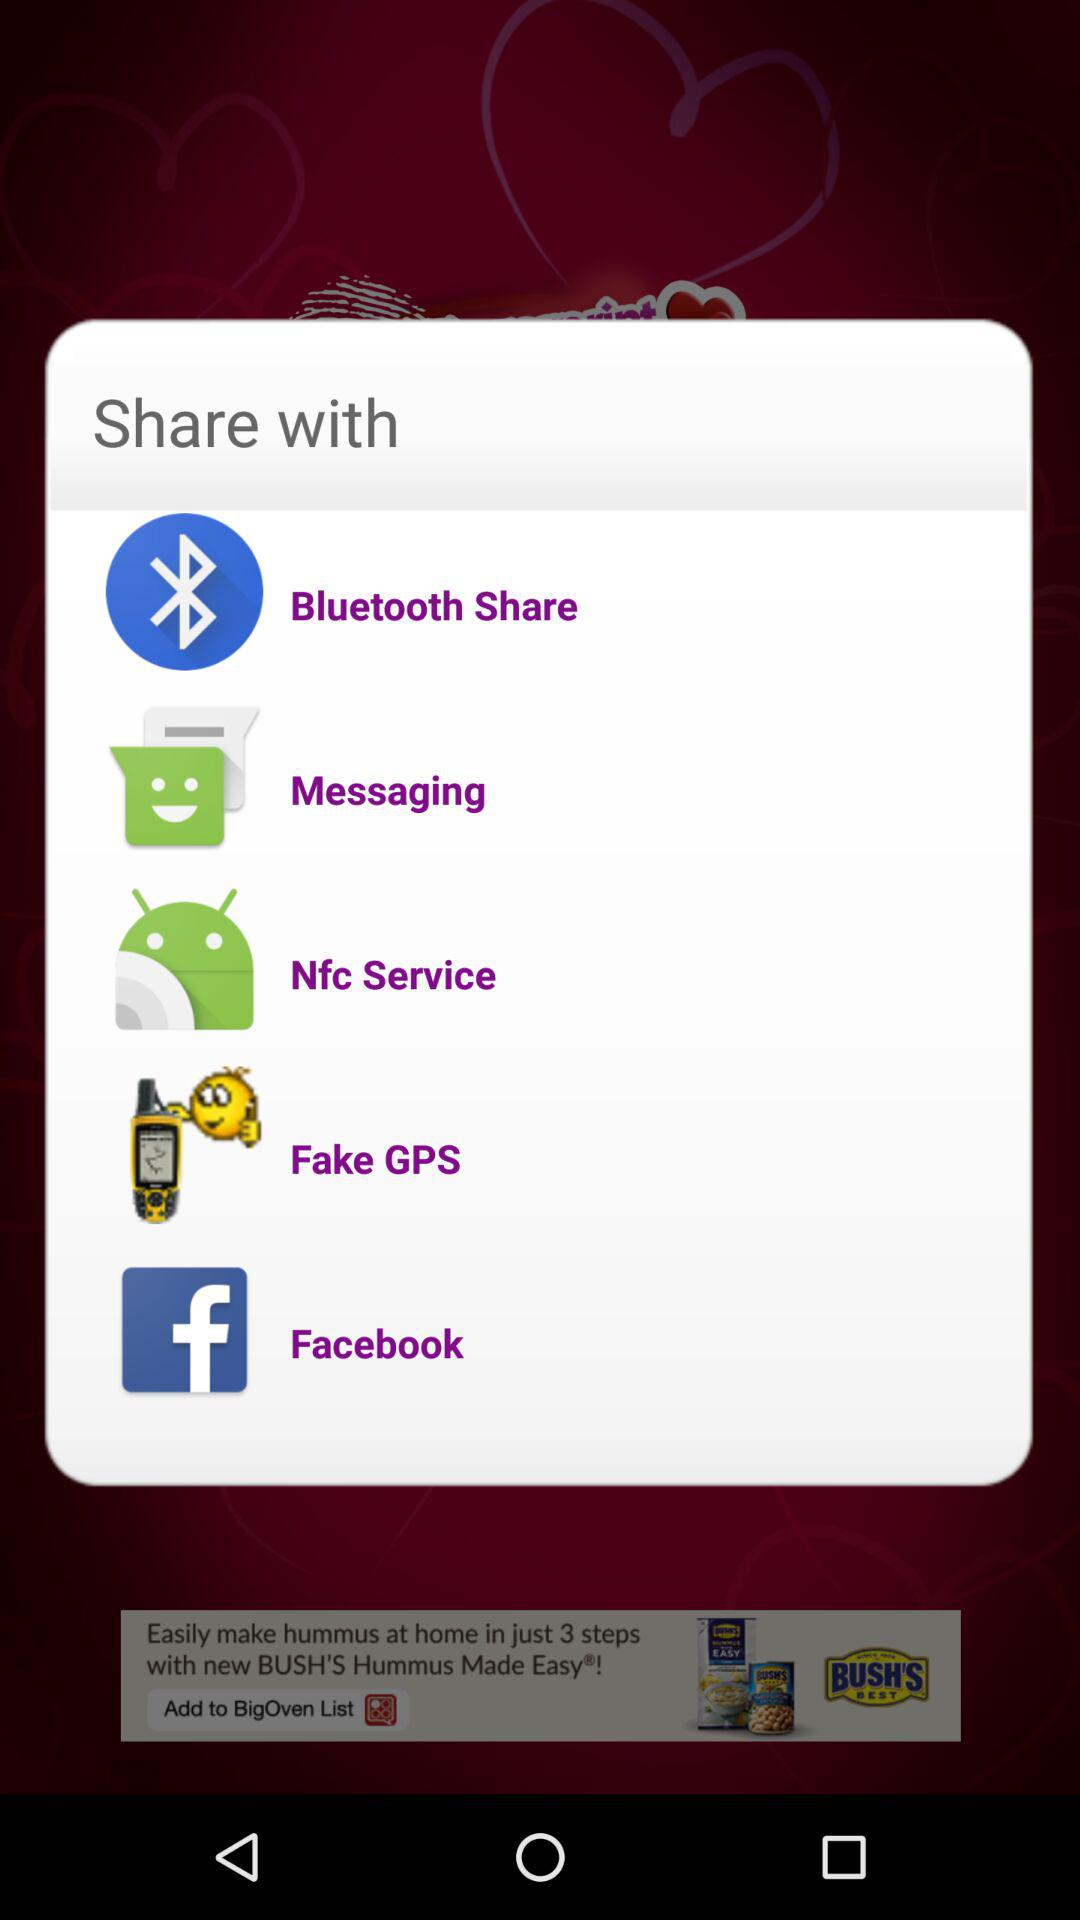How many items are under the Share with header?
Answer the question using a single word or phrase. 5 